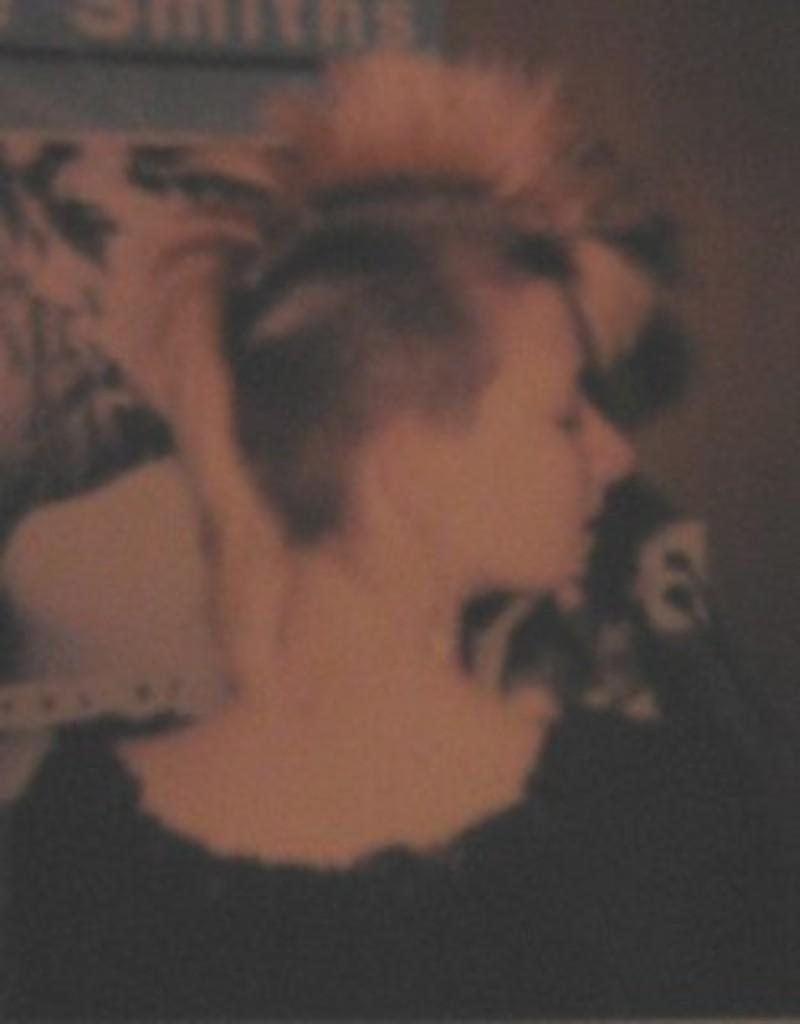Describe this image in one or two sentences. There is a person in black color dress. And the background is blurred. 